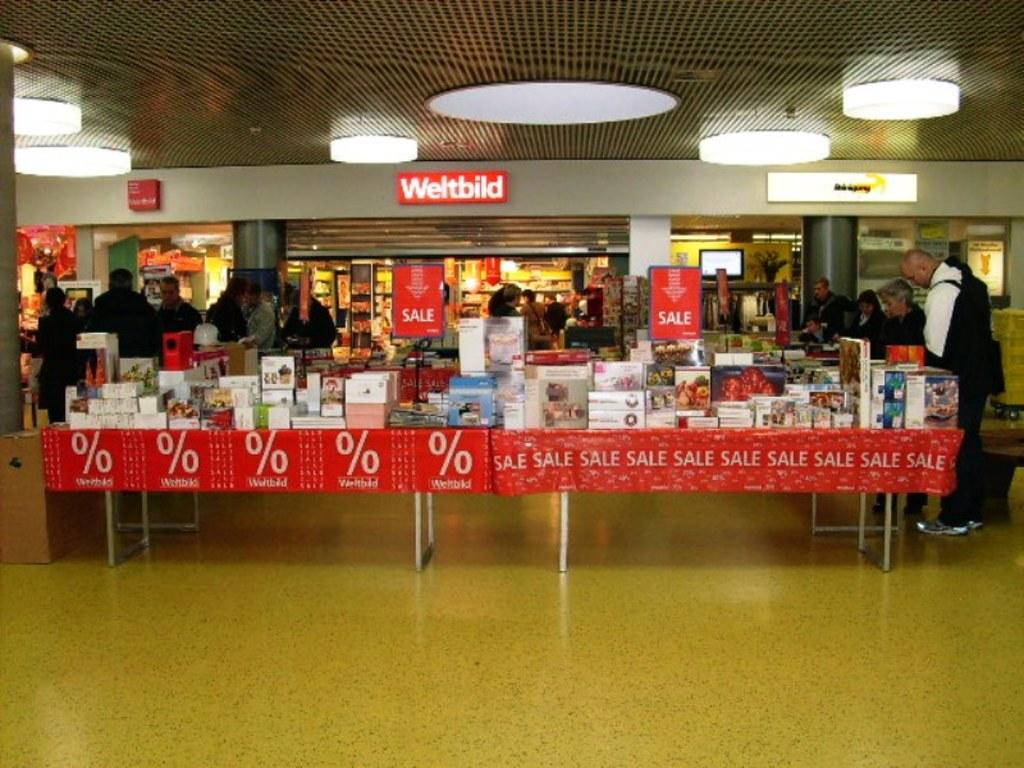<image>
Offer a succinct explanation of the picture presented. A table in a store sits under a sign that says Weldbild  advertises a sale. 